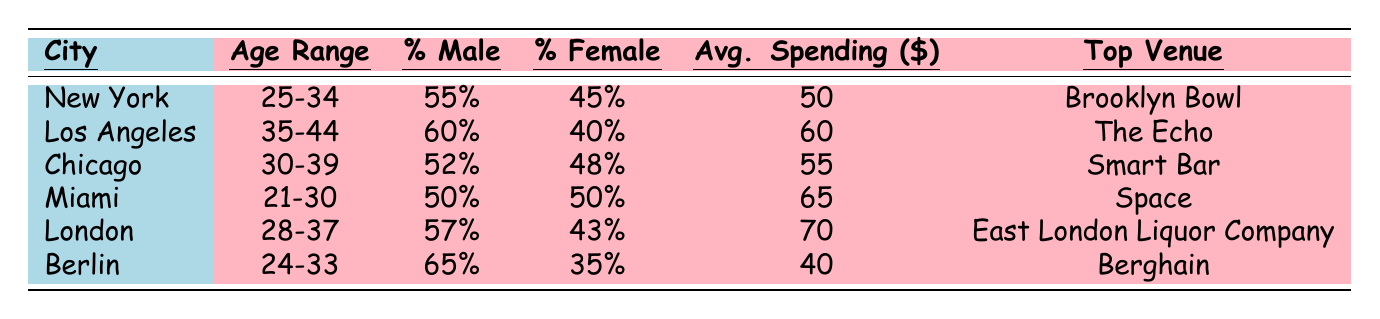What is the average spending for 80s-themed DJ events in New York? The table shows that the average spending in New York is listed as 50 dollars.
Answer: 50 Which city has the highest percentage of male attendees? The table highlights that Berlin has the highest percentage of male attendees at 65%.
Answer: 65% What percentage of attendees in Miami are female? In the Miami row, the table indicates the percentage of female attendees is 50%.
Answer: 50% Is the average spending higher in London than in Chicago? The average spending in London is 70 dollars while in Chicago it is 55 dollars. Thus, London has higher spending.
Answer: Yes What is the difference in average spending between Los Angeles and Miami? The average spending in Los Angeles is 60 dollars and in Miami is 65 dollars. The difference is 65 - 60 = 5 dollars.
Answer: 5 Which city has an equal percentage of male and female attendees? The table shows that in Miami, both male and female attendees are equal at 50%.
Answer: Miami If we consider the average spending of the top three cities (New York, Los Angeles, Chicago), what is their average spending? The average spending for these cities is 50 (New York) + 60 (Los Angeles) + 55 (Chicago) = 165. Divided by 3 gives 165/3 = 55 dollars.
Answer: 55 Which city has the lowest average spending and what is that amount? The Berlin row shows the lowest average spending at 40 dollars.
Answer: 40 What is the most popular venue in Chicago? According to the table, the most popular venue listed for Chicago is Smart Bar.
Answer: Smart Bar How many cities have an average spending over 60 dollars? The cities are Los Angeles (60), London (70), and Miami (65). Among these, London and Miami both exceed 60 dollars, making it 2 cities.
Answer: 2 